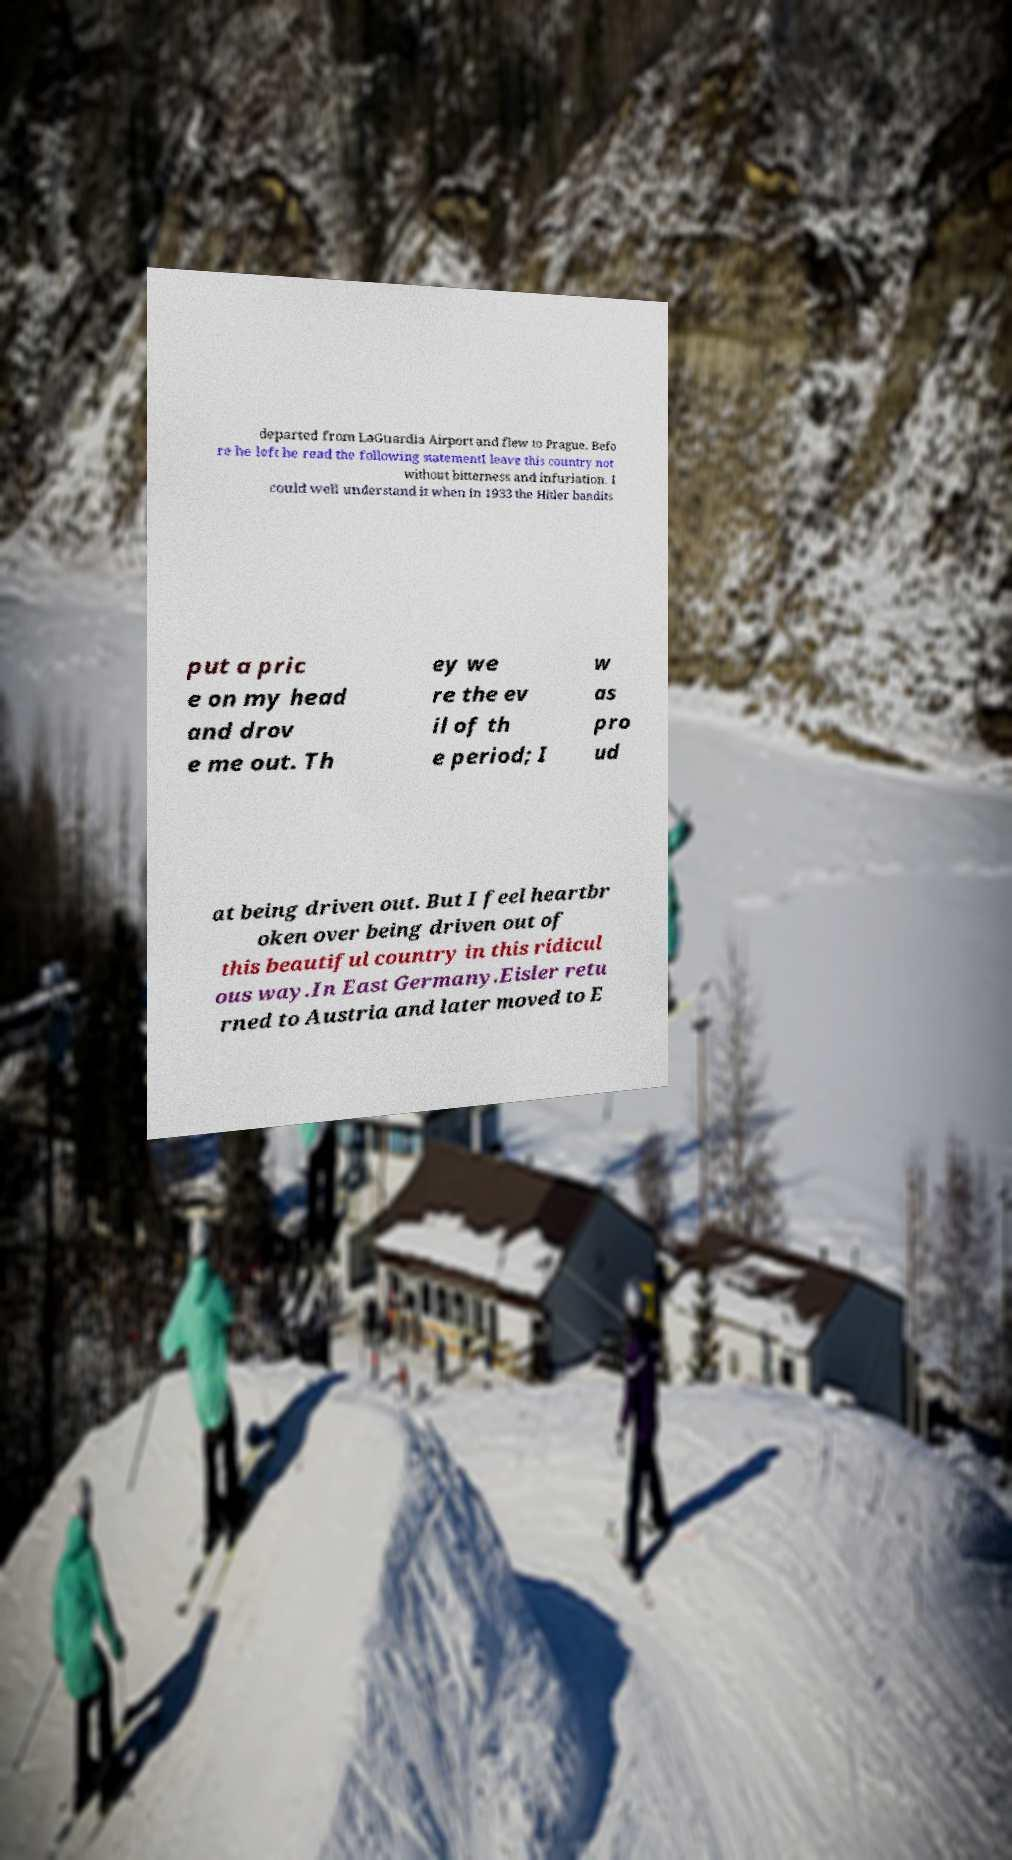Could you extract and type out the text from this image? departed from LaGuardia Airport and flew to Prague. Befo re he left he read the following statementI leave this country not without bitterness and infuriation. I could well understand it when in 1933 the Hitler bandits put a pric e on my head and drov e me out. Th ey we re the ev il of th e period; I w as pro ud at being driven out. But I feel heartbr oken over being driven out of this beautiful country in this ridicul ous way.In East Germany.Eisler retu rned to Austria and later moved to E 